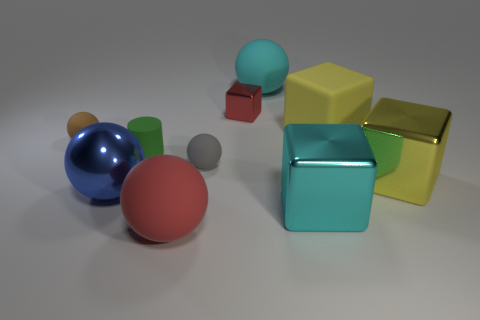Are there any other things that have the same shape as the tiny green rubber object?
Keep it short and to the point. No. There is another ball that is the same size as the brown ball; what material is it?
Give a very brief answer. Rubber. Is there a red rubber sphere of the same size as the cyan matte ball?
Provide a short and direct response. Yes. What is the color of the tiny block?
Your answer should be very brief. Red. There is a large metal object to the left of the red thing that is in front of the large rubber cube; what is its color?
Provide a short and direct response. Blue. There is a large cyan object that is behind the cyan object that is in front of the cyan thing left of the cyan shiny thing; what is its shape?
Provide a short and direct response. Sphere. How many red things are made of the same material as the green cylinder?
Provide a short and direct response. 1. How many large cyan objects are on the left side of the big sphere behind the small green cylinder?
Make the answer very short. 0. How many tiny yellow shiny spheres are there?
Offer a terse response. 0. Does the big red thing have the same material as the large object behind the tiny metal thing?
Keep it short and to the point. Yes. 